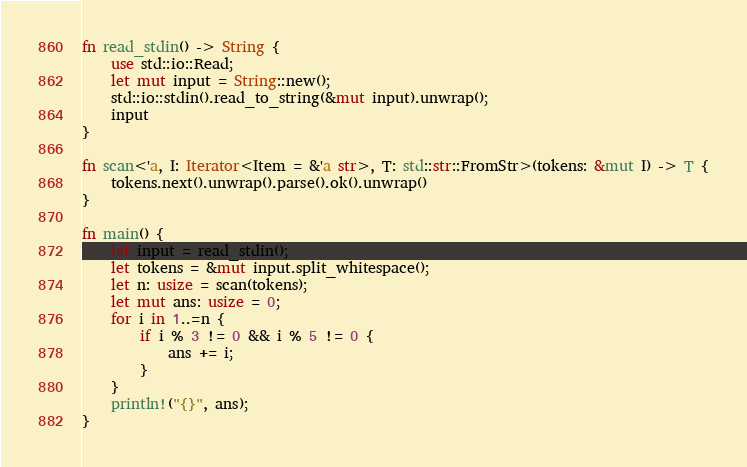<code> <loc_0><loc_0><loc_500><loc_500><_Rust_>fn read_stdin() -> String {
    use std::io::Read;
    let mut input = String::new();
    std::io::stdin().read_to_string(&mut input).unwrap();
    input
}

fn scan<'a, I: Iterator<Item = &'a str>, T: std::str::FromStr>(tokens: &mut I) -> T {
    tokens.next().unwrap().parse().ok().unwrap()
}

fn main() {
    let input = read_stdin();
    let tokens = &mut input.split_whitespace();
    let n: usize = scan(tokens);
    let mut ans: usize = 0;
    for i in 1..=n {
        if i % 3 != 0 && i % 5 != 0 {
            ans += i;
        }
    }
    println!("{}", ans);
}
</code> 